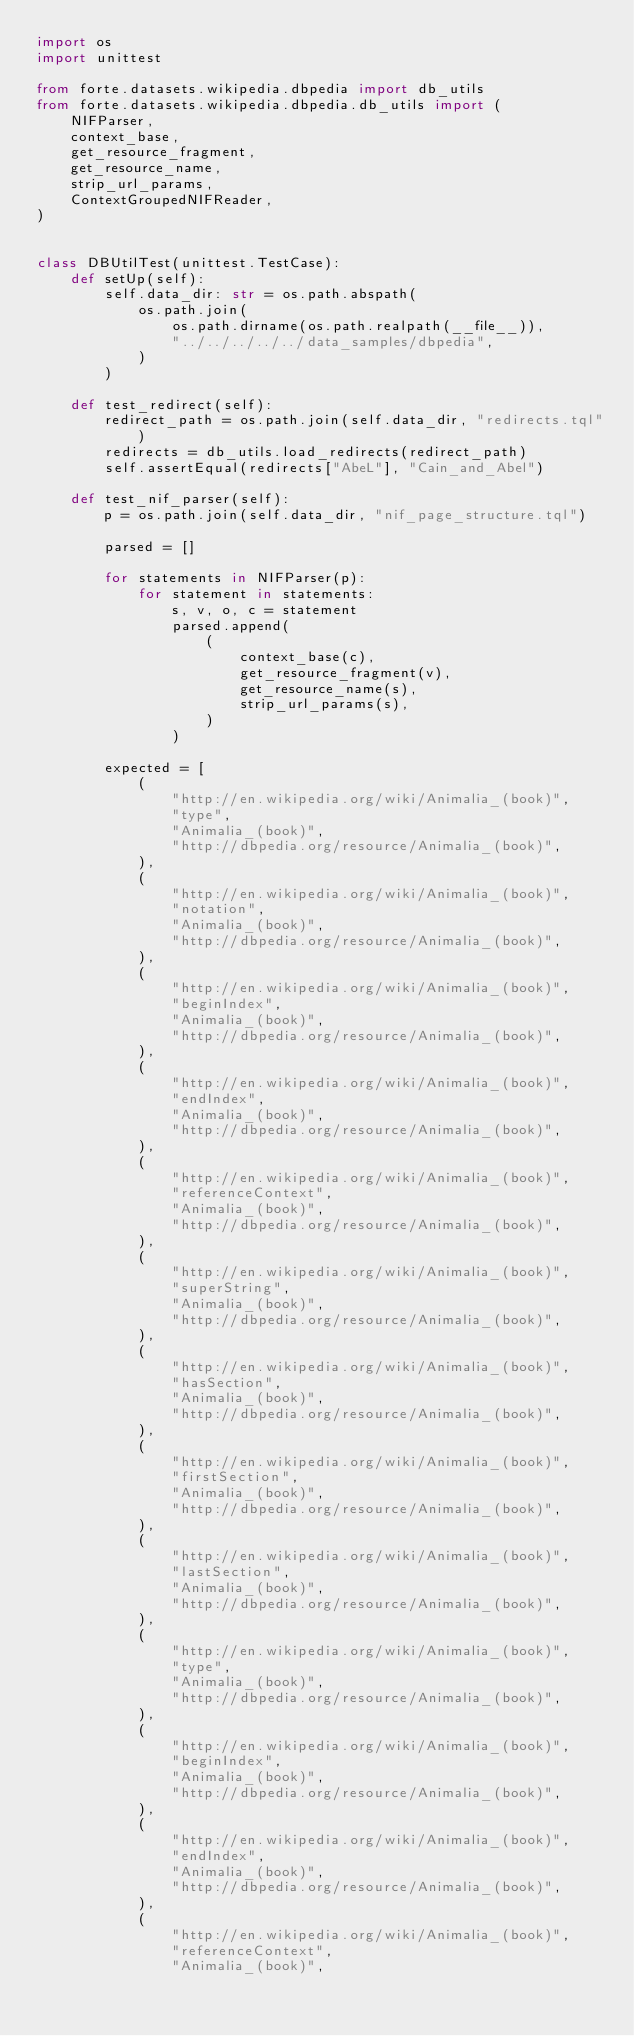<code> <loc_0><loc_0><loc_500><loc_500><_Python_>import os
import unittest

from forte.datasets.wikipedia.dbpedia import db_utils
from forte.datasets.wikipedia.dbpedia.db_utils import (
    NIFParser,
    context_base,
    get_resource_fragment,
    get_resource_name,
    strip_url_params,
    ContextGroupedNIFReader,
)


class DBUtilTest(unittest.TestCase):
    def setUp(self):
        self.data_dir: str = os.path.abspath(
            os.path.join(
                os.path.dirname(os.path.realpath(__file__)),
                "../../../../../data_samples/dbpedia",
            )
        )

    def test_redirect(self):
        redirect_path = os.path.join(self.data_dir, "redirects.tql")
        redirects = db_utils.load_redirects(redirect_path)
        self.assertEqual(redirects["AbeL"], "Cain_and_Abel")

    def test_nif_parser(self):
        p = os.path.join(self.data_dir, "nif_page_structure.tql")

        parsed = []

        for statements in NIFParser(p):
            for statement in statements:
                s, v, o, c = statement
                parsed.append(
                    (
                        context_base(c),
                        get_resource_fragment(v),
                        get_resource_name(s),
                        strip_url_params(s),
                    )
                )

        expected = [
            (
                "http://en.wikipedia.org/wiki/Animalia_(book)",
                "type",
                "Animalia_(book)",
                "http://dbpedia.org/resource/Animalia_(book)",
            ),
            (
                "http://en.wikipedia.org/wiki/Animalia_(book)",
                "notation",
                "Animalia_(book)",
                "http://dbpedia.org/resource/Animalia_(book)",
            ),
            (
                "http://en.wikipedia.org/wiki/Animalia_(book)",
                "beginIndex",
                "Animalia_(book)",
                "http://dbpedia.org/resource/Animalia_(book)",
            ),
            (
                "http://en.wikipedia.org/wiki/Animalia_(book)",
                "endIndex",
                "Animalia_(book)",
                "http://dbpedia.org/resource/Animalia_(book)",
            ),
            (
                "http://en.wikipedia.org/wiki/Animalia_(book)",
                "referenceContext",
                "Animalia_(book)",
                "http://dbpedia.org/resource/Animalia_(book)",
            ),
            (
                "http://en.wikipedia.org/wiki/Animalia_(book)",
                "superString",
                "Animalia_(book)",
                "http://dbpedia.org/resource/Animalia_(book)",
            ),
            (
                "http://en.wikipedia.org/wiki/Animalia_(book)",
                "hasSection",
                "Animalia_(book)",
                "http://dbpedia.org/resource/Animalia_(book)",
            ),
            (
                "http://en.wikipedia.org/wiki/Animalia_(book)",
                "firstSection",
                "Animalia_(book)",
                "http://dbpedia.org/resource/Animalia_(book)",
            ),
            (
                "http://en.wikipedia.org/wiki/Animalia_(book)",
                "lastSection",
                "Animalia_(book)",
                "http://dbpedia.org/resource/Animalia_(book)",
            ),
            (
                "http://en.wikipedia.org/wiki/Animalia_(book)",
                "type",
                "Animalia_(book)",
                "http://dbpedia.org/resource/Animalia_(book)",
            ),
            (
                "http://en.wikipedia.org/wiki/Animalia_(book)",
                "beginIndex",
                "Animalia_(book)",
                "http://dbpedia.org/resource/Animalia_(book)",
            ),
            (
                "http://en.wikipedia.org/wiki/Animalia_(book)",
                "endIndex",
                "Animalia_(book)",
                "http://dbpedia.org/resource/Animalia_(book)",
            ),
            (
                "http://en.wikipedia.org/wiki/Animalia_(book)",
                "referenceContext",
                "Animalia_(book)",</code> 